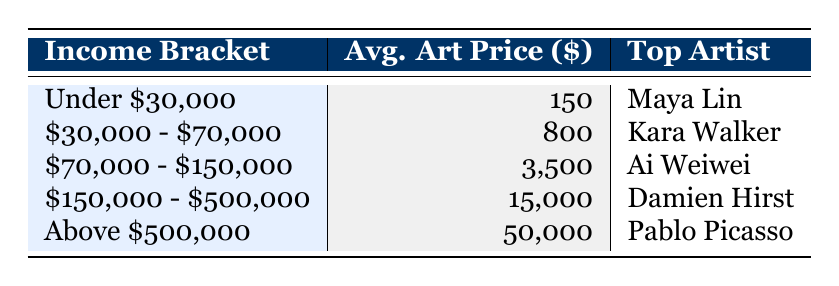What is the average art price in the income bracket "Under $30,000"? The table indicates that the average art price in the "Under $30,000" income bracket is listed directly. Therefore, I can see it is 150.
Answer: 150 Which artist is noted as the top artist for the "$150,000 - $500,000" income bracket? I can check the table under the "$150,000 - $500,000" income bracket, and it clearly states that the top artist is Damien Hirst.
Answer: Damien Hirst What is the total art sales value for the "$30,000 - $70,000" income bracket and the "$70,000 - $150,000" bracket combined? I sum up the total art sales for both brackets: 12000 (for "$30,000 - $70,000") + 8000 (for "$70,000 - $150,000") = 20000.
Answer: 20000 Is the average art price in the income bracket "Above $500,000" greater than $40,000? The average art price for the "Above $500,000" income bracket is directly listed in the table as 50000, which is greater than 40000.
Answer: Yes What is the difference in average art price between the "Under $30,000" and "Above $500,000" income brackets? I subtract the average art price of the "Under $30,000" bracket (150) from that of the "Above $500,000" bracket (50000): 50000 - 150 = 49850.
Answer: 49850 Which is the most popular art style among the "Under $30,000" income bracket? The table specifies that the popular art styles for the "Under $30,000" bracket include "Abstract" and "Pop Art."
Answer: Abstract and Pop Art What is the average art price for all income brackets listed? To find the average, I compute the sum of the average prices for each income bracket: (150 + 800 + 3500 + 15000 + 50000) = 61800. Then, I divide by the number of brackets (5): 61800 / 5 = 12360.
Answer: 12360 Are "Surrealism" and "Contemporary" both listed as popular art styles? I check the popular art styles in their respective income brackets: "Surrealism" is in the "$70,000 - $150,000" bracket and "Contemporary" is in the "$150,000 - $500,000" bracket. Thus, both styles are indeed present.
Answer: Yes Which income bracket has the lowest total art sales? By comparing the total art sales for each bracket, I observe that the "$150,000 - $500,000" income bracket has the lowest total at 3000.
Answer: $150,000 - $500,000 If you compare the total art sales of the "Under $30,000" and "$30,000 - $70,000" brackets, which one is higher? The total art sales for "Under $30,000" is 5000 and for "$30,000 - $70,000" is 12000. Since 12000 is greater than 5000, the "$30,000 - $70,000" bracket has higher sales.
Answer: $30,000 - $70,000 